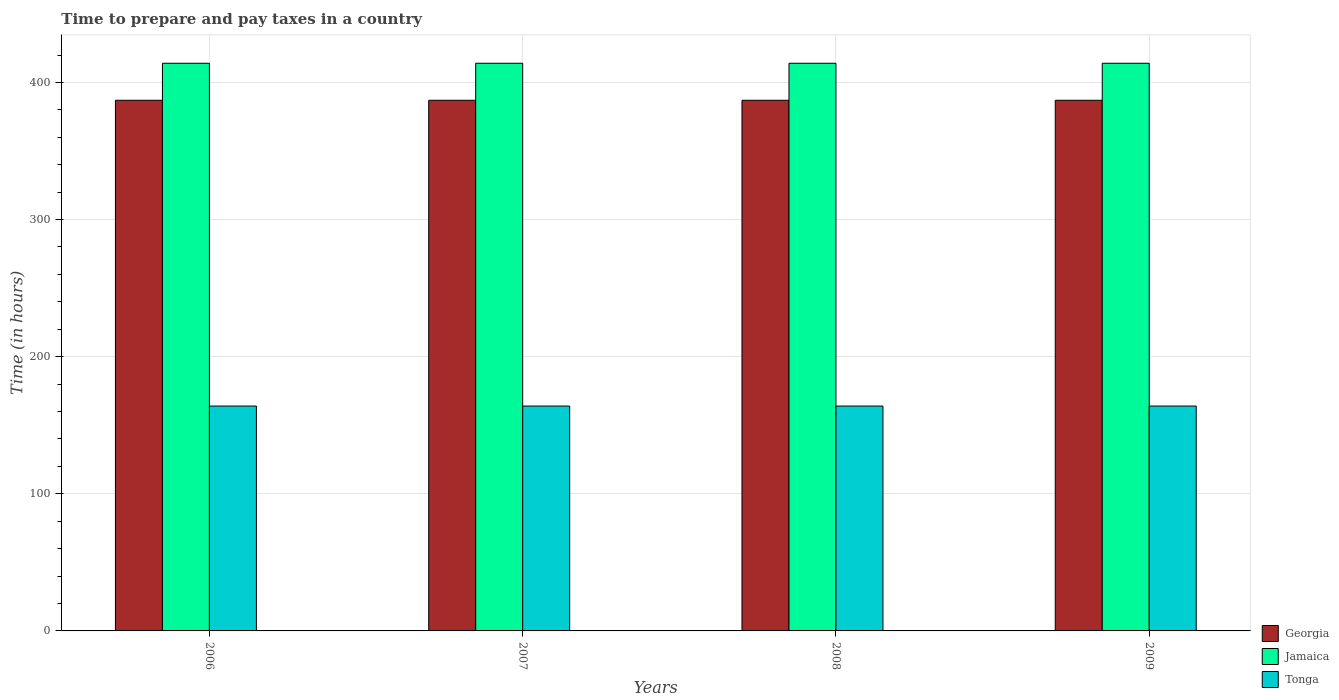How many different coloured bars are there?
Offer a terse response. 3. How many groups of bars are there?
Offer a terse response. 4. Are the number of bars per tick equal to the number of legend labels?
Provide a succinct answer. Yes. Are the number of bars on each tick of the X-axis equal?
Offer a very short reply. Yes. How many bars are there on the 3rd tick from the right?
Provide a short and direct response. 3. What is the label of the 3rd group of bars from the left?
Ensure brevity in your answer.  2008. What is the number of hours required to prepare and pay taxes in Tonga in 2006?
Your answer should be compact. 164. Across all years, what is the maximum number of hours required to prepare and pay taxes in Jamaica?
Provide a short and direct response. 414. Across all years, what is the minimum number of hours required to prepare and pay taxes in Georgia?
Your response must be concise. 387. What is the total number of hours required to prepare and pay taxes in Tonga in the graph?
Provide a short and direct response. 656. What is the difference between the number of hours required to prepare and pay taxes in Jamaica in 2007 and that in 2008?
Give a very brief answer. 0. What is the difference between the number of hours required to prepare and pay taxes in Tonga in 2008 and the number of hours required to prepare and pay taxes in Georgia in 2007?
Offer a terse response. -223. What is the average number of hours required to prepare and pay taxes in Tonga per year?
Make the answer very short. 164. In the year 2007, what is the difference between the number of hours required to prepare and pay taxes in Jamaica and number of hours required to prepare and pay taxes in Tonga?
Your response must be concise. 250. In how many years, is the number of hours required to prepare and pay taxes in Tonga greater than 300 hours?
Your response must be concise. 0. What is the ratio of the number of hours required to prepare and pay taxes in Jamaica in 2007 to that in 2009?
Your answer should be very brief. 1. Is the difference between the number of hours required to prepare and pay taxes in Jamaica in 2006 and 2009 greater than the difference between the number of hours required to prepare and pay taxes in Tonga in 2006 and 2009?
Provide a short and direct response. No. What is the difference between the highest and the second highest number of hours required to prepare and pay taxes in Georgia?
Provide a short and direct response. 0. What is the difference between the highest and the lowest number of hours required to prepare and pay taxes in Tonga?
Keep it short and to the point. 0. In how many years, is the number of hours required to prepare and pay taxes in Tonga greater than the average number of hours required to prepare and pay taxes in Tonga taken over all years?
Make the answer very short. 0. What does the 2nd bar from the left in 2009 represents?
Make the answer very short. Jamaica. What does the 1st bar from the right in 2008 represents?
Your answer should be very brief. Tonga. Is it the case that in every year, the sum of the number of hours required to prepare and pay taxes in Georgia and number of hours required to prepare and pay taxes in Tonga is greater than the number of hours required to prepare and pay taxes in Jamaica?
Your response must be concise. Yes. How many bars are there?
Your response must be concise. 12. Are all the bars in the graph horizontal?
Provide a succinct answer. No. How many years are there in the graph?
Offer a terse response. 4. Are the values on the major ticks of Y-axis written in scientific E-notation?
Your response must be concise. No. Does the graph contain grids?
Ensure brevity in your answer.  Yes. How many legend labels are there?
Your answer should be very brief. 3. How are the legend labels stacked?
Your answer should be very brief. Vertical. What is the title of the graph?
Ensure brevity in your answer.  Time to prepare and pay taxes in a country. Does "Chile" appear as one of the legend labels in the graph?
Your answer should be very brief. No. What is the label or title of the X-axis?
Provide a short and direct response. Years. What is the label or title of the Y-axis?
Provide a short and direct response. Time (in hours). What is the Time (in hours) in Georgia in 2006?
Keep it short and to the point. 387. What is the Time (in hours) in Jamaica in 2006?
Offer a terse response. 414. What is the Time (in hours) in Tonga in 2006?
Provide a succinct answer. 164. What is the Time (in hours) of Georgia in 2007?
Your response must be concise. 387. What is the Time (in hours) in Jamaica in 2007?
Provide a succinct answer. 414. What is the Time (in hours) of Tonga in 2007?
Ensure brevity in your answer.  164. What is the Time (in hours) in Georgia in 2008?
Ensure brevity in your answer.  387. What is the Time (in hours) of Jamaica in 2008?
Ensure brevity in your answer.  414. What is the Time (in hours) in Tonga in 2008?
Provide a short and direct response. 164. What is the Time (in hours) of Georgia in 2009?
Your response must be concise. 387. What is the Time (in hours) of Jamaica in 2009?
Provide a succinct answer. 414. What is the Time (in hours) of Tonga in 2009?
Offer a terse response. 164. Across all years, what is the maximum Time (in hours) of Georgia?
Offer a terse response. 387. Across all years, what is the maximum Time (in hours) in Jamaica?
Provide a succinct answer. 414. Across all years, what is the maximum Time (in hours) of Tonga?
Provide a short and direct response. 164. Across all years, what is the minimum Time (in hours) in Georgia?
Offer a terse response. 387. Across all years, what is the minimum Time (in hours) of Jamaica?
Provide a succinct answer. 414. Across all years, what is the minimum Time (in hours) in Tonga?
Ensure brevity in your answer.  164. What is the total Time (in hours) of Georgia in the graph?
Provide a short and direct response. 1548. What is the total Time (in hours) in Jamaica in the graph?
Offer a very short reply. 1656. What is the total Time (in hours) in Tonga in the graph?
Make the answer very short. 656. What is the difference between the Time (in hours) in Georgia in 2006 and that in 2007?
Offer a terse response. 0. What is the difference between the Time (in hours) in Jamaica in 2006 and that in 2007?
Provide a succinct answer. 0. What is the difference between the Time (in hours) in Tonga in 2006 and that in 2007?
Offer a very short reply. 0. What is the difference between the Time (in hours) in Jamaica in 2006 and that in 2008?
Keep it short and to the point. 0. What is the difference between the Time (in hours) of Tonga in 2006 and that in 2008?
Keep it short and to the point. 0. What is the difference between the Time (in hours) of Georgia in 2006 and that in 2009?
Your response must be concise. 0. What is the difference between the Time (in hours) in Jamaica in 2006 and that in 2009?
Offer a very short reply. 0. What is the difference between the Time (in hours) in Tonga in 2006 and that in 2009?
Offer a very short reply. 0. What is the difference between the Time (in hours) of Jamaica in 2007 and that in 2008?
Your response must be concise. 0. What is the difference between the Time (in hours) of Tonga in 2007 and that in 2009?
Ensure brevity in your answer.  0. What is the difference between the Time (in hours) of Tonga in 2008 and that in 2009?
Make the answer very short. 0. What is the difference between the Time (in hours) of Georgia in 2006 and the Time (in hours) of Jamaica in 2007?
Offer a terse response. -27. What is the difference between the Time (in hours) of Georgia in 2006 and the Time (in hours) of Tonga in 2007?
Your response must be concise. 223. What is the difference between the Time (in hours) of Jamaica in 2006 and the Time (in hours) of Tonga in 2007?
Keep it short and to the point. 250. What is the difference between the Time (in hours) in Georgia in 2006 and the Time (in hours) in Tonga in 2008?
Your answer should be compact. 223. What is the difference between the Time (in hours) in Jamaica in 2006 and the Time (in hours) in Tonga in 2008?
Your response must be concise. 250. What is the difference between the Time (in hours) in Georgia in 2006 and the Time (in hours) in Jamaica in 2009?
Make the answer very short. -27. What is the difference between the Time (in hours) in Georgia in 2006 and the Time (in hours) in Tonga in 2009?
Provide a short and direct response. 223. What is the difference between the Time (in hours) of Jamaica in 2006 and the Time (in hours) of Tonga in 2009?
Offer a very short reply. 250. What is the difference between the Time (in hours) of Georgia in 2007 and the Time (in hours) of Jamaica in 2008?
Keep it short and to the point. -27. What is the difference between the Time (in hours) in Georgia in 2007 and the Time (in hours) in Tonga in 2008?
Ensure brevity in your answer.  223. What is the difference between the Time (in hours) of Jamaica in 2007 and the Time (in hours) of Tonga in 2008?
Provide a succinct answer. 250. What is the difference between the Time (in hours) in Georgia in 2007 and the Time (in hours) in Tonga in 2009?
Provide a succinct answer. 223. What is the difference between the Time (in hours) of Jamaica in 2007 and the Time (in hours) of Tonga in 2009?
Make the answer very short. 250. What is the difference between the Time (in hours) in Georgia in 2008 and the Time (in hours) in Jamaica in 2009?
Your answer should be compact. -27. What is the difference between the Time (in hours) in Georgia in 2008 and the Time (in hours) in Tonga in 2009?
Offer a terse response. 223. What is the difference between the Time (in hours) in Jamaica in 2008 and the Time (in hours) in Tonga in 2009?
Make the answer very short. 250. What is the average Time (in hours) of Georgia per year?
Provide a short and direct response. 387. What is the average Time (in hours) in Jamaica per year?
Provide a succinct answer. 414. What is the average Time (in hours) in Tonga per year?
Provide a succinct answer. 164. In the year 2006, what is the difference between the Time (in hours) of Georgia and Time (in hours) of Tonga?
Provide a succinct answer. 223. In the year 2006, what is the difference between the Time (in hours) of Jamaica and Time (in hours) of Tonga?
Keep it short and to the point. 250. In the year 2007, what is the difference between the Time (in hours) of Georgia and Time (in hours) of Jamaica?
Your answer should be compact. -27. In the year 2007, what is the difference between the Time (in hours) of Georgia and Time (in hours) of Tonga?
Keep it short and to the point. 223. In the year 2007, what is the difference between the Time (in hours) of Jamaica and Time (in hours) of Tonga?
Offer a terse response. 250. In the year 2008, what is the difference between the Time (in hours) of Georgia and Time (in hours) of Jamaica?
Offer a very short reply. -27. In the year 2008, what is the difference between the Time (in hours) of Georgia and Time (in hours) of Tonga?
Your answer should be very brief. 223. In the year 2008, what is the difference between the Time (in hours) of Jamaica and Time (in hours) of Tonga?
Give a very brief answer. 250. In the year 2009, what is the difference between the Time (in hours) of Georgia and Time (in hours) of Jamaica?
Keep it short and to the point. -27. In the year 2009, what is the difference between the Time (in hours) of Georgia and Time (in hours) of Tonga?
Your answer should be very brief. 223. In the year 2009, what is the difference between the Time (in hours) in Jamaica and Time (in hours) in Tonga?
Give a very brief answer. 250. What is the ratio of the Time (in hours) of Georgia in 2006 to that in 2007?
Your response must be concise. 1. What is the ratio of the Time (in hours) of Tonga in 2006 to that in 2007?
Give a very brief answer. 1. What is the ratio of the Time (in hours) of Georgia in 2006 to that in 2008?
Provide a succinct answer. 1. What is the ratio of the Time (in hours) of Tonga in 2006 to that in 2008?
Your response must be concise. 1. What is the ratio of the Time (in hours) in Georgia in 2006 to that in 2009?
Offer a very short reply. 1. What is the ratio of the Time (in hours) in Jamaica in 2007 to that in 2008?
Give a very brief answer. 1. What is the ratio of the Time (in hours) of Tonga in 2007 to that in 2008?
Make the answer very short. 1. What is the ratio of the Time (in hours) of Jamaica in 2007 to that in 2009?
Your answer should be compact. 1. What is the ratio of the Time (in hours) of Georgia in 2008 to that in 2009?
Offer a terse response. 1. What is the ratio of the Time (in hours) in Jamaica in 2008 to that in 2009?
Ensure brevity in your answer.  1. What is the difference between the highest and the second highest Time (in hours) in Georgia?
Your answer should be compact. 0. What is the difference between the highest and the second highest Time (in hours) in Jamaica?
Provide a short and direct response. 0. What is the difference between the highest and the second highest Time (in hours) in Tonga?
Offer a terse response. 0. What is the difference between the highest and the lowest Time (in hours) in Georgia?
Offer a terse response. 0. What is the difference between the highest and the lowest Time (in hours) in Jamaica?
Keep it short and to the point. 0. What is the difference between the highest and the lowest Time (in hours) of Tonga?
Give a very brief answer. 0. 